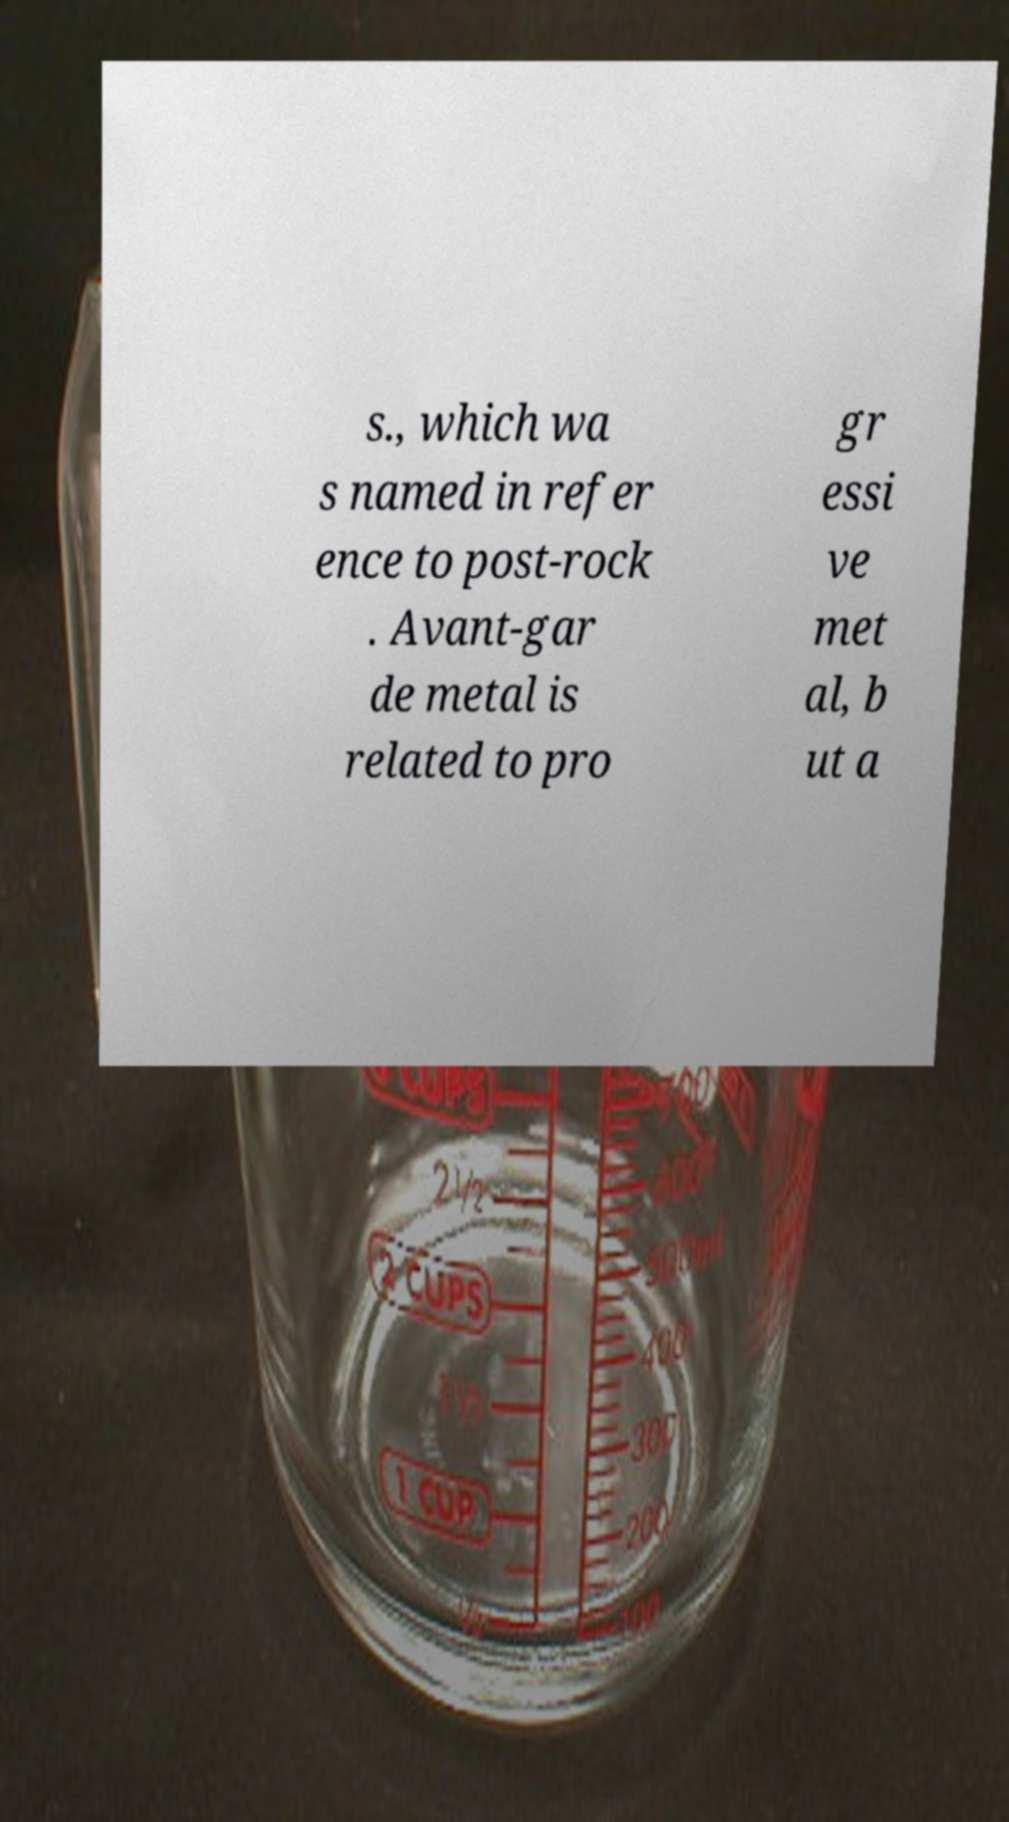For documentation purposes, I need the text within this image transcribed. Could you provide that? s., which wa s named in refer ence to post-rock . Avant-gar de metal is related to pro gr essi ve met al, b ut a 